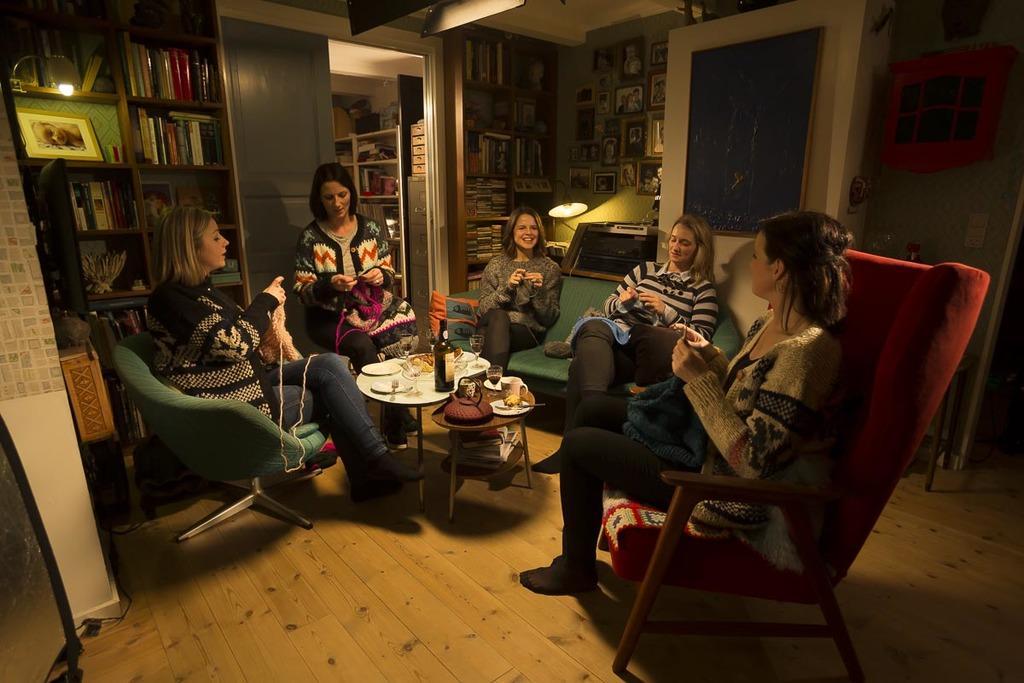Please provide a concise description of this image. Here we see 5 ladies who are sitting on chairs. They are sewing clothes. In front of them there is a small table on which we can see alcohol bottle, glass, plates present. Behind the left most lady we can see a shelf in which books are placed in same order. On the wall we have photo frames present. 